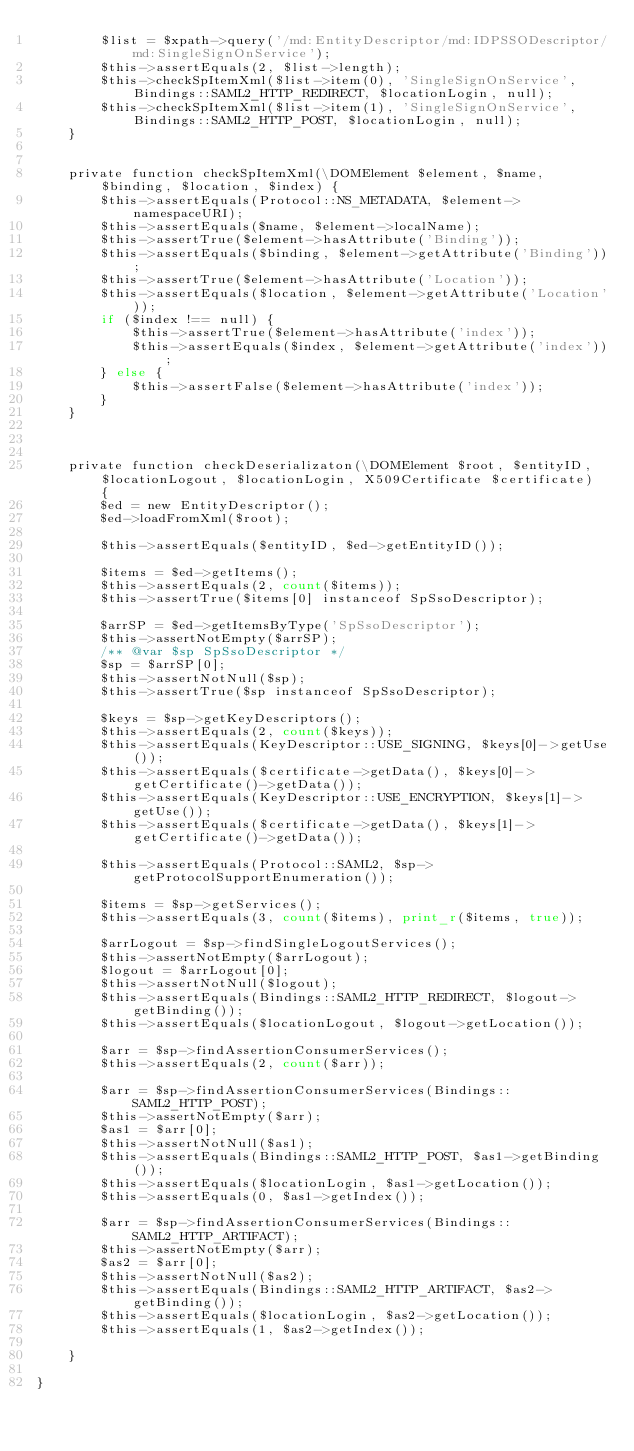<code> <loc_0><loc_0><loc_500><loc_500><_PHP_>        $list = $xpath->query('/md:EntityDescriptor/md:IDPSSODescriptor/md:SingleSignOnService');
        $this->assertEquals(2, $list->length);
        $this->checkSpItemXml($list->item(0), 'SingleSignOnService', Bindings::SAML2_HTTP_REDIRECT, $locationLogin, null);
        $this->checkSpItemXml($list->item(1), 'SingleSignOnService', Bindings::SAML2_HTTP_POST, $locationLogin, null);
    }


    private function checkSpItemXml(\DOMElement $element, $name, $binding, $location, $index) {
        $this->assertEquals(Protocol::NS_METADATA, $element->namespaceURI);
        $this->assertEquals($name, $element->localName);
        $this->assertTrue($element->hasAttribute('Binding'));
        $this->assertEquals($binding, $element->getAttribute('Binding'));
        $this->assertTrue($element->hasAttribute('Location'));
        $this->assertEquals($location, $element->getAttribute('Location'));
        if ($index !== null) {
            $this->assertTrue($element->hasAttribute('index'));
            $this->assertEquals($index, $element->getAttribute('index'));
        } else {
            $this->assertFalse($element->hasAttribute('index'));
        }
    }



    private function checkDeserializaton(\DOMElement $root, $entityID, $locationLogout, $locationLogin, X509Certificate $certificate) {
        $ed = new EntityDescriptor();
        $ed->loadFromXml($root);

        $this->assertEquals($entityID, $ed->getEntityID());

        $items = $ed->getItems();
        $this->assertEquals(2, count($items));
        $this->assertTrue($items[0] instanceof SpSsoDescriptor);

        $arrSP = $ed->getItemsByType('SpSsoDescriptor');
        $this->assertNotEmpty($arrSP);
        /** @var $sp SpSsoDescriptor */
        $sp = $arrSP[0];
        $this->assertNotNull($sp);
        $this->assertTrue($sp instanceof SpSsoDescriptor);

        $keys = $sp->getKeyDescriptors();
        $this->assertEquals(2, count($keys));
        $this->assertEquals(KeyDescriptor::USE_SIGNING, $keys[0]->getUse());
        $this->assertEquals($certificate->getData(), $keys[0]->getCertificate()->getData());
        $this->assertEquals(KeyDescriptor::USE_ENCRYPTION, $keys[1]->getUse());
        $this->assertEquals($certificate->getData(), $keys[1]->getCertificate()->getData());

        $this->assertEquals(Protocol::SAML2, $sp->getProtocolSupportEnumeration());

        $items = $sp->getServices();
        $this->assertEquals(3, count($items), print_r($items, true));

        $arrLogout = $sp->findSingleLogoutServices();
        $this->assertNotEmpty($arrLogout);
        $logout = $arrLogout[0];
        $this->assertNotNull($logout);
        $this->assertEquals(Bindings::SAML2_HTTP_REDIRECT, $logout->getBinding());
        $this->assertEquals($locationLogout, $logout->getLocation());

        $arr = $sp->findAssertionConsumerServices();
        $this->assertEquals(2, count($arr));

        $arr = $sp->findAssertionConsumerServices(Bindings::SAML2_HTTP_POST);
        $this->assertNotEmpty($arr);
        $as1 = $arr[0];
        $this->assertNotNull($as1);
        $this->assertEquals(Bindings::SAML2_HTTP_POST, $as1->getBinding());
        $this->assertEquals($locationLogin, $as1->getLocation());
        $this->assertEquals(0, $as1->getIndex());

        $arr = $sp->findAssertionConsumerServices(Bindings::SAML2_HTTP_ARTIFACT);
        $this->assertNotEmpty($arr);
        $as2 = $arr[0];
        $this->assertNotNull($as2);
        $this->assertEquals(Bindings::SAML2_HTTP_ARTIFACT, $as2->getBinding());
        $this->assertEquals($locationLogin, $as2->getLocation());
        $this->assertEquals(1, $as2->getIndex());

    }

}</code> 